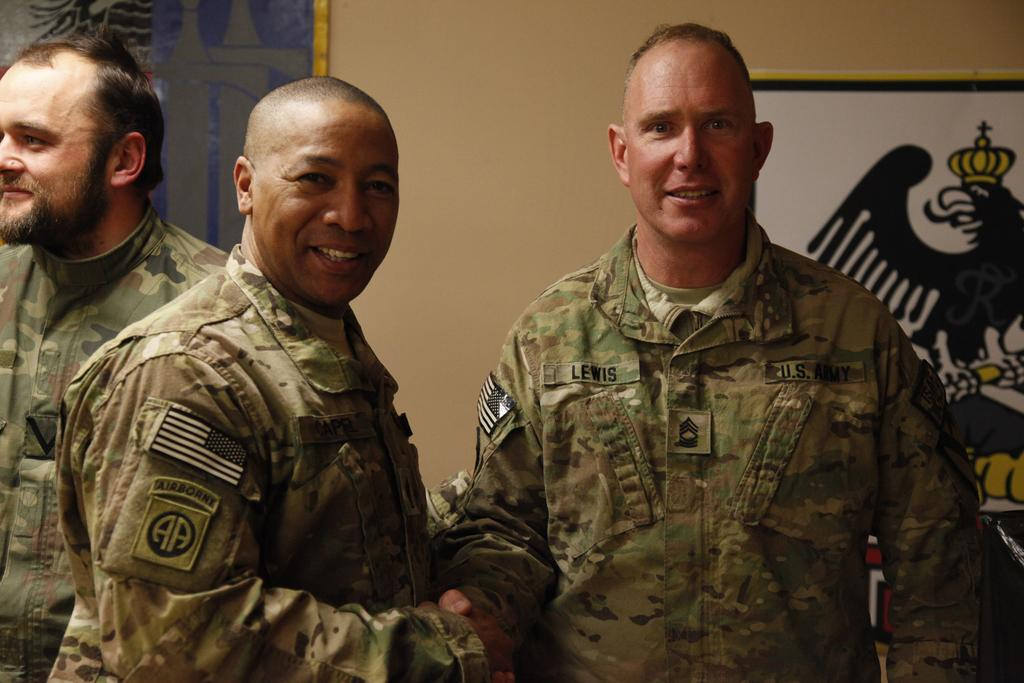What is the main focus of the image? The main focus of the image is the people in the center. What can be seen in the background of the image? There are portraits in the background area of the image. What theory is being produced by the people in the image? There is no indication in the image that the people are producing or discussing any theories. 